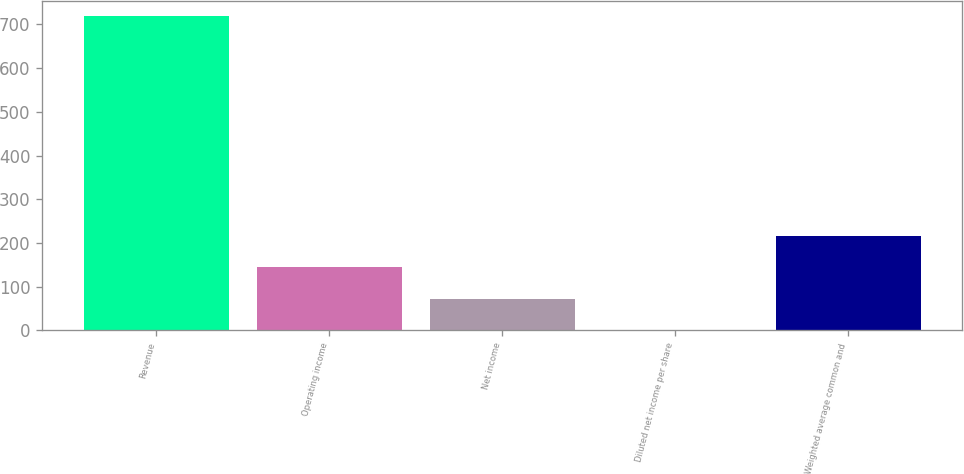Convert chart. <chart><loc_0><loc_0><loc_500><loc_500><bar_chart><fcel>Revenue<fcel>Operating income<fcel>Net income<fcel>Diluted net income per share<fcel>Weighted average common and<nl><fcel>718.6<fcel>144.08<fcel>72.26<fcel>0.44<fcel>215.9<nl></chart> 